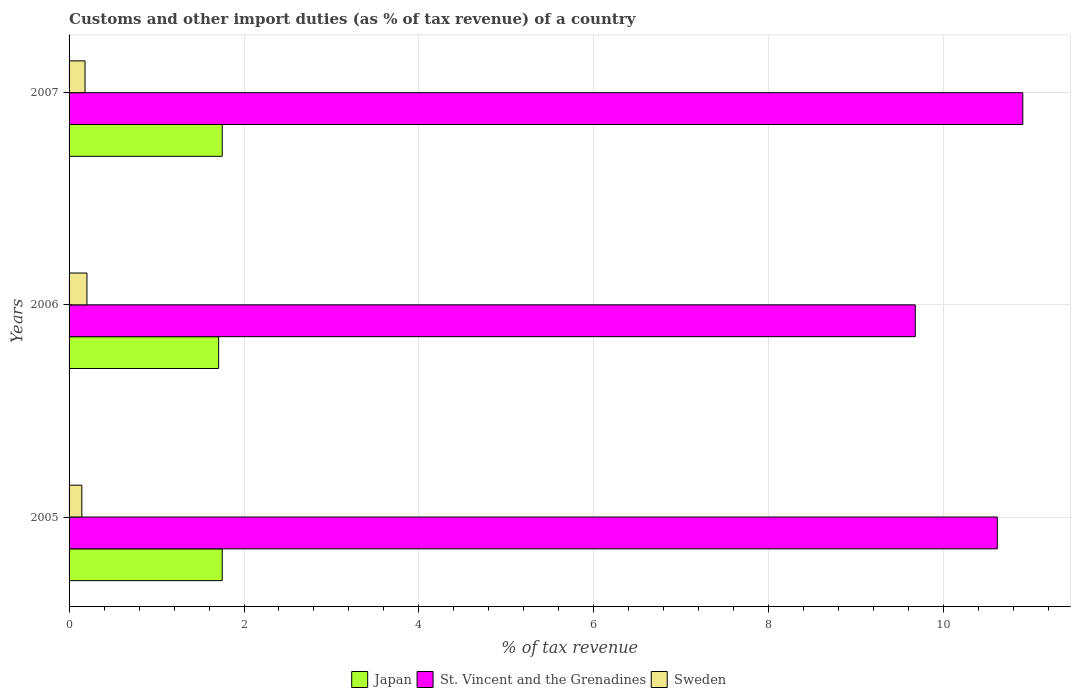How many groups of bars are there?
Provide a short and direct response. 3. How many bars are there on the 3rd tick from the bottom?
Your answer should be very brief. 3. What is the label of the 3rd group of bars from the top?
Ensure brevity in your answer.  2005. What is the percentage of tax revenue from customs in Sweden in 2007?
Offer a terse response. 0.18. Across all years, what is the maximum percentage of tax revenue from customs in St. Vincent and the Grenadines?
Offer a very short reply. 10.9. Across all years, what is the minimum percentage of tax revenue from customs in Sweden?
Your answer should be compact. 0.15. In which year was the percentage of tax revenue from customs in St. Vincent and the Grenadines maximum?
Offer a terse response. 2007. In which year was the percentage of tax revenue from customs in Japan minimum?
Provide a succinct answer. 2006. What is the total percentage of tax revenue from customs in St. Vincent and the Grenadines in the graph?
Make the answer very short. 31.19. What is the difference between the percentage of tax revenue from customs in Sweden in 2005 and that in 2006?
Keep it short and to the point. -0.06. What is the difference between the percentage of tax revenue from customs in Japan in 2005 and the percentage of tax revenue from customs in Sweden in 2007?
Your answer should be compact. 1.57. What is the average percentage of tax revenue from customs in St. Vincent and the Grenadines per year?
Your answer should be very brief. 10.4. In the year 2007, what is the difference between the percentage of tax revenue from customs in St. Vincent and the Grenadines and percentage of tax revenue from customs in Sweden?
Your answer should be compact. 10.72. What is the ratio of the percentage of tax revenue from customs in Japan in 2005 to that in 2007?
Your answer should be compact. 1. Is the percentage of tax revenue from customs in Sweden in 2006 less than that in 2007?
Give a very brief answer. No. Is the difference between the percentage of tax revenue from customs in St. Vincent and the Grenadines in 2005 and 2006 greater than the difference between the percentage of tax revenue from customs in Sweden in 2005 and 2006?
Provide a short and direct response. Yes. What is the difference between the highest and the second highest percentage of tax revenue from customs in Japan?
Ensure brevity in your answer.  0. What is the difference between the highest and the lowest percentage of tax revenue from customs in Sweden?
Ensure brevity in your answer.  0.06. Is the sum of the percentage of tax revenue from customs in Japan in 2005 and 2007 greater than the maximum percentage of tax revenue from customs in St. Vincent and the Grenadines across all years?
Give a very brief answer. No. What does the 1st bar from the bottom in 2005 represents?
Offer a terse response. Japan. Is it the case that in every year, the sum of the percentage of tax revenue from customs in Japan and percentage of tax revenue from customs in Sweden is greater than the percentage of tax revenue from customs in St. Vincent and the Grenadines?
Give a very brief answer. No. How many bars are there?
Make the answer very short. 9. How many years are there in the graph?
Ensure brevity in your answer.  3. Where does the legend appear in the graph?
Provide a short and direct response. Bottom center. How many legend labels are there?
Provide a short and direct response. 3. How are the legend labels stacked?
Give a very brief answer. Horizontal. What is the title of the graph?
Make the answer very short. Customs and other import duties (as % of tax revenue) of a country. Does "Tonga" appear as one of the legend labels in the graph?
Give a very brief answer. No. What is the label or title of the X-axis?
Your answer should be compact. % of tax revenue. What is the label or title of the Y-axis?
Offer a very short reply. Years. What is the % of tax revenue in Japan in 2005?
Your response must be concise. 1.75. What is the % of tax revenue of St. Vincent and the Grenadines in 2005?
Make the answer very short. 10.61. What is the % of tax revenue in Sweden in 2005?
Make the answer very short. 0.15. What is the % of tax revenue of Japan in 2006?
Provide a short and direct response. 1.71. What is the % of tax revenue of St. Vincent and the Grenadines in 2006?
Your answer should be compact. 9.67. What is the % of tax revenue of Sweden in 2006?
Offer a terse response. 0.2. What is the % of tax revenue in Japan in 2007?
Make the answer very short. 1.75. What is the % of tax revenue of St. Vincent and the Grenadines in 2007?
Provide a short and direct response. 10.9. What is the % of tax revenue of Sweden in 2007?
Your response must be concise. 0.18. Across all years, what is the maximum % of tax revenue of Japan?
Your response must be concise. 1.75. Across all years, what is the maximum % of tax revenue in St. Vincent and the Grenadines?
Provide a succinct answer. 10.9. Across all years, what is the maximum % of tax revenue of Sweden?
Provide a short and direct response. 0.2. Across all years, what is the minimum % of tax revenue in Japan?
Offer a very short reply. 1.71. Across all years, what is the minimum % of tax revenue in St. Vincent and the Grenadines?
Offer a very short reply. 9.67. Across all years, what is the minimum % of tax revenue of Sweden?
Your answer should be very brief. 0.15. What is the total % of tax revenue of Japan in the graph?
Give a very brief answer. 5.21. What is the total % of tax revenue of St. Vincent and the Grenadines in the graph?
Give a very brief answer. 31.19. What is the total % of tax revenue of Sweden in the graph?
Offer a terse response. 0.53. What is the difference between the % of tax revenue of Japan in 2005 and that in 2006?
Offer a terse response. 0.04. What is the difference between the % of tax revenue in St. Vincent and the Grenadines in 2005 and that in 2006?
Your answer should be very brief. 0.94. What is the difference between the % of tax revenue in Sweden in 2005 and that in 2006?
Provide a short and direct response. -0.06. What is the difference between the % of tax revenue of Japan in 2005 and that in 2007?
Provide a succinct answer. -0. What is the difference between the % of tax revenue of St. Vincent and the Grenadines in 2005 and that in 2007?
Keep it short and to the point. -0.29. What is the difference between the % of tax revenue of Sweden in 2005 and that in 2007?
Your response must be concise. -0.04. What is the difference between the % of tax revenue in Japan in 2006 and that in 2007?
Offer a very short reply. -0.04. What is the difference between the % of tax revenue of St. Vincent and the Grenadines in 2006 and that in 2007?
Ensure brevity in your answer.  -1.23. What is the difference between the % of tax revenue of Sweden in 2006 and that in 2007?
Your answer should be very brief. 0.02. What is the difference between the % of tax revenue of Japan in 2005 and the % of tax revenue of St. Vincent and the Grenadines in 2006?
Your answer should be very brief. -7.92. What is the difference between the % of tax revenue in Japan in 2005 and the % of tax revenue in Sweden in 2006?
Provide a short and direct response. 1.55. What is the difference between the % of tax revenue of St. Vincent and the Grenadines in 2005 and the % of tax revenue of Sweden in 2006?
Give a very brief answer. 10.41. What is the difference between the % of tax revenue in Japan in 2005 and the % of tax revenue in St. Vincent and the Grenadines in 2007?
Give a very brief answer. -9.15. What is the difference between the % of tax revenue in Japan in 2005 and the % of tax revenue in Sweden in 2007?
Your answer should be very brief. 1.57. What is the difference between the % of tax revenue in St. Vincent and the Grenadines in 2005 and the % of tax revenue in Sweden in 2007?
Your answer should be compact. 10.43. What is the difference between the % of tax revenue of Japan in 2006 and the % of tax revenue of St. Vincent and the Grenadines in 2007?
Give a very brief answer. -9.19. What is the difference between the % of tax revenue of Japan in 2006 and the % of tax revenue of Sweden in 2007?
Your response must be concise. 1.53. What is the difference between the % of tax revenue in St. Vincent and the Grenadines in 2006 and the % of tax revenue in Sweden in 2007?
Provide a short and direct response. 9.49. What is the average % of tax revenue in Japan per year?
Provide a short and direct response. 1.74. What is the average % of tax revenue in St. Vincent and the Grenadines per year?
Offer a very short reply. 10.4. What is the average % of tax revenue of Sweden per year?
Your response must be concise. 0.18. In the year 2005, what is the difference between the % of tax revenue of Japan and % of tax revenue of St. Vincent and the Grenadines?
Ensure brevity in your answer.  -8.86. In the year 2005, what is the difference between the % of tax revenue of Japan and % of tax revenue of Sweden?
Ensure brevity in your answer.  1.61. In the year 2005, what is the difference between the % of tax revenue of St. Vincent and the Grenadines and % of tax revenue of Sweden?
Your response must be concise. 10.47. In the year 2006, what is the difference between the % of tax revenue of Japan and % of tax revenue of St. Vincent and the Grenadines?
Your answer should be compact. -7.96. In the year 2006, what is the difference between the % of tax revenue of Japan and % of tax revenue of Sweden?
Your answer should be compact. 1.51. In the year 2006, what is the difference between the % of tax revenue in St. Vincent and the Grenadines and % of tax revenue in Sweden?
Keep it short and to the point. 9.47. In the year 2007, what is the difference between the % of tax revenue of Japan and % of tax revenue of St. Vincent and the Grenadines?
Offer a very short reply. -9.15. In the year 2007, what is the difference between the % of tax revenue in Japan and % of tax revenue in Sweden?
Offer a very short reply. 1.57. In the year 2007, what is the difference between the % of tax revenue of St. Vincent and the Grenadines and % of tax revenue of Sweden?
Your answer should be very brief. 10.72. What is the ratio of the % of tax revenue in Japan in 2005 to that in 2006?
Keep it short and to the point. 1.02. What is the ratio of the % of tax revenue of St. Vincent and the Grenadines in 2005 to that in 2006?
Your answer should be compact. 1.1. What is the ratio of the % of tax revenue in Sweden in 2005 to that in 2006?
Your answer should be very brief. 0.71. What is the ratio of the % of tax revenue in St. Vincent and the Grenadines in 2005 to that in 2007?
Your answer should be compact. 0.97. What is the ratio of the % of tax revenue in Sweden in 2005 to that in 2007?
Keep it short and to the point. 0.8. What is the ratio of the % of tax revenue in Japan in 2006 to that in 2007?
Provide a succinct answer. 0.98. What is the ratio of the % of tax revenue of St. Vincent and the Grenadines in 2006 to that in 2007?
Offer a very short reply. 0.89. What is the ratio of the % of tax revenue of Sweden in 2006 to that in 2007?
Ensure brevity in your answer.  1.12. What is the difference between the highest and the second highest % of tax revenue in Japan?
Make the answer very short. 0. What is the difference between the highest and the second highest % of tax revenue of St. Vincent and the Grenadines?
Your answer should be very brief. 0.29. What is the difference between the highest and the second highest % of tax revenue of Sweden?
Your response must be concise. 0.02. What is the difference between the highest and the lowest % of tax revenue in Japan?
Provide a succinct answer. 0.04. What is the difference between the highest and the lowest % of tax revenue in St. Vincent and the Grenadines?
Offer a very short reply. 1.23. What is the difference between the highest and the lowest % of tax revenue of Sweden?
Provide a succinct answer. 0.06. 